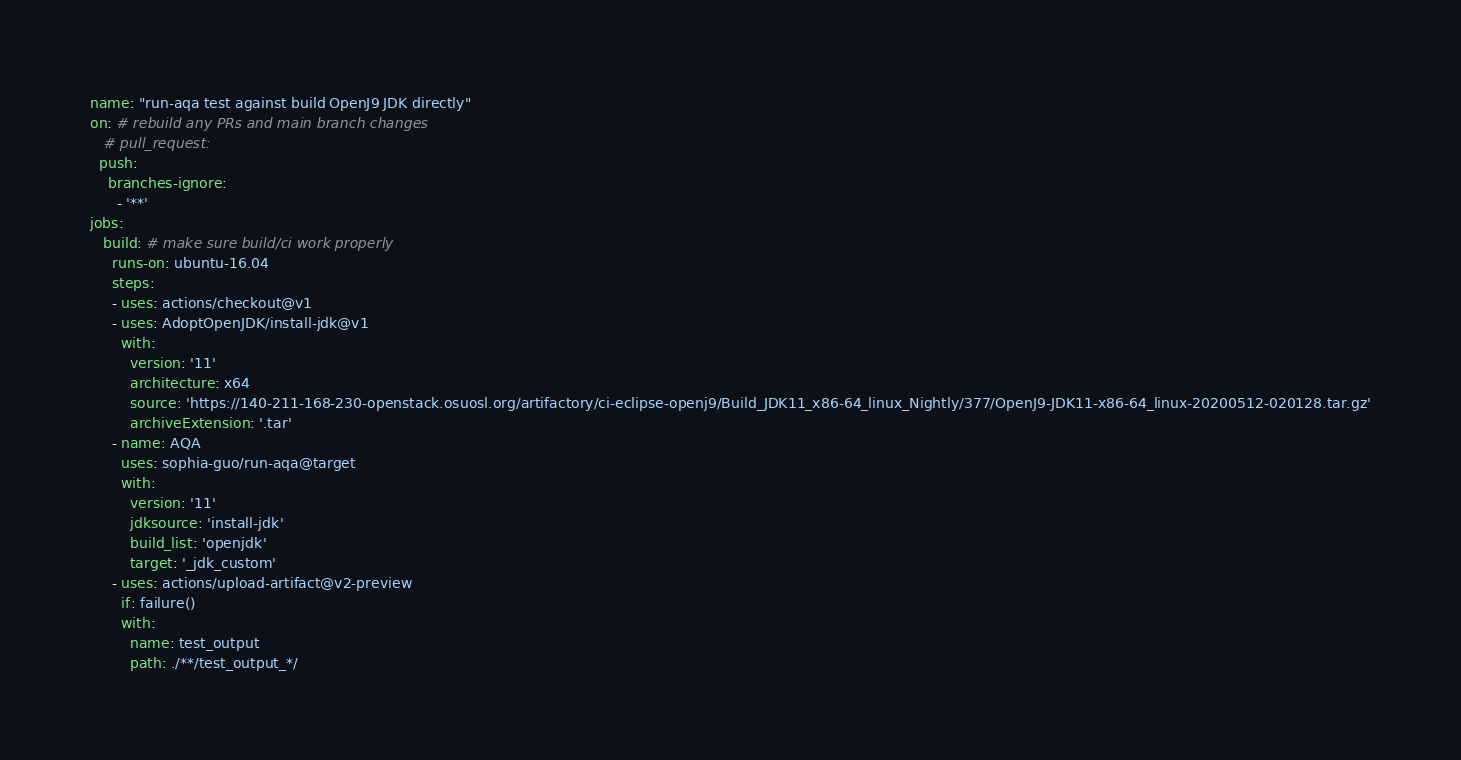Convert code to text. <code><loc_0><loc_0><loc_500><loc_500><_YAML_>
name: "run-aqa test against build OpenJ9 JDK directly"
on: # rebuild any PRs and main branch changes
   # pull_request:
  push:
    branches-ignore:
      - '**'
jobs:
   build: # make sure build/ci work properly
     runs-on: ubuntu-16.04
     steps:
     - uses: actions/checkout@v1
     - uses: AdoptOpenJDK/install-jdk@v1
       with:
         version: '11'
         architecture: x64
         source: 'https://140-211-168-230-openstack.osuosl.org/artifactory/ci-eclipse-openj9/Build_JDK11_x86-64_linux_Nightly/377/OpenJ9-JDK11-x86-64_linux-20200512-020128.tar.gz'
         archiveExtension: '.tar'
     - name: AQA
       uses: sophia-guo/run-aqa@target
       with: 
         version: '11'
         jdksource: 'install-jdk'
         build_list: 'openjdk'
         target: '_jdk_custom'
     - uses: actions/upload-artifact@v2-preview
       if: failure()
       with:
         name: test_output
         path: ./**/test_output_*/</code> 